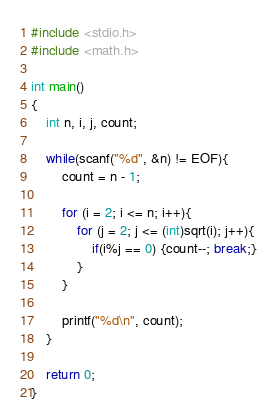Convert code to text. <code><loc_0><loc_0><loc_500><loc_500><_C_>#include <stdio.h>
#include <math.h>

int main()
{
	int n, i, j, count;

	while(scanf("%d", &n) != EOF){
		count = n - 1;

		for (i = 2; i <= n; i++){
			for (j = 2; j <= (int)sqrt(i); j++){
				if(i%j == 0) {count--; break;}
			}
		}

		printf("%d\n", count);
	}

	return 0;
}</code> 